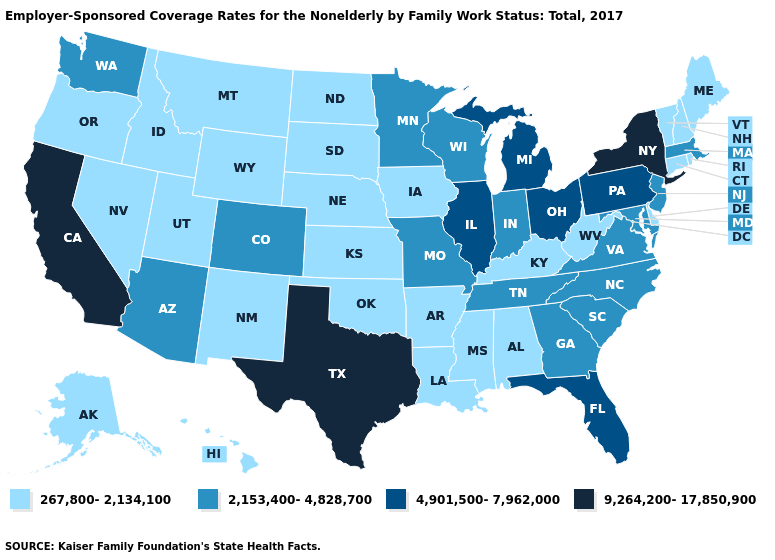Name the states that have a value in the range 4,901,500-7,962,000?
Quick response, please. Florida, Illinois, Michigan, Ohio, Pennsylvania. Name the states that have a value in the range 4,901,500-7,962,000?
Give a very brief answer. Florida, Illinois, Michigan, Ohio, Pennsylvania. Does Tennessee have the highest value in the USA?
Concise answer only. No. Does the map have missing data?
Quick response, please. No. What is the lowest value in the USA?
Keep it brief. 267,800-2,134,100. Name the states that have a value in the range 267,800-2,134,100?
Quick response, please. Alabama, Alaska, Arkansas, Connecticut, Delaware, Hawaii, Idaho, Iowa, Kansas, Kentucky, Louisiana, Maine, Mississippi, Montana, Nebraska, Nevada, New Hampshire, New Mexico, North Dakota, Oklahoma, Oregon, Rhode Island, South Dakota, Utah, Vermont, West Virginia, Wyoming. What is the value of Hawaii?
Concise answer only. 267,800-2,134,100. Does the map have missing data?
Concise answer only. No. Name the states that have a value in the range 4,901,500-7,962,000?
Concise answer only. Florida, Illinois, Michigan, Ohio, Pennsylvania. What is the value of Arizona?
Quick response, please. 2,153,400-4,828,700. What is the highest value in the MidWest ?
Concise answer only. 4,901,500-7,962,000. Name the states that have a value in the range 2,153,400-4,828,700?
Give a very brief answer. Arizona, Colorado, Georgia, Indiana, Maryland, Massachusetts, Minnesota, Missouri, New Jersey, North Carolina, South Carolina, Tennessee, Virginia, Washington, Wisconsin. Name the states that have a value in the range 9,264,200-17,850,900?
Concise answer only. California, New York, Texas. What is the lowest value in the USA?
Keep it brief. 267,800-2,134,100. What is the lowest value in the West?
Quick response, please. 267,800-2,134,100. 